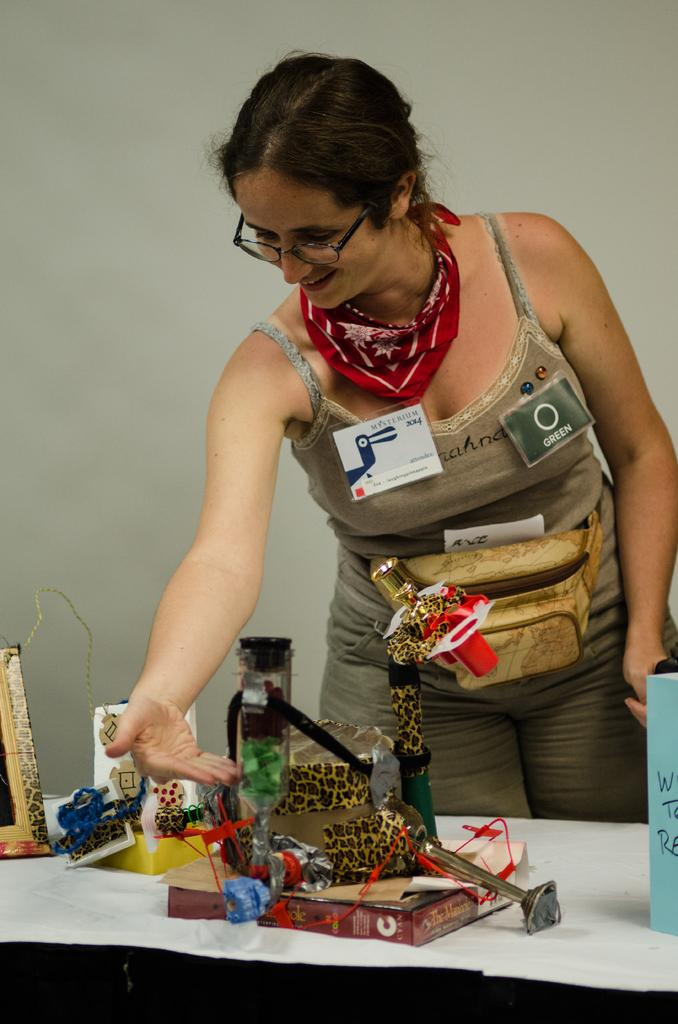What is the main subject of the image? There is a lady standing in the image. Can you describe the lady's attire? The lady is wearing badges, a bag, a scarf, and glasses. What is in front of the lady? There is a table in front of the lady. What can be seen on the table? There are many items on the table. What is visible in the background of the image? There is a wall in the background of the image. How many clams are sitting on the table in the image? There are no clams present in the image. What type of lizards can be seen crawling on the wall in the image? There are no lizards visible in the image; only the lady, her attire, the table, and the wall are present. 